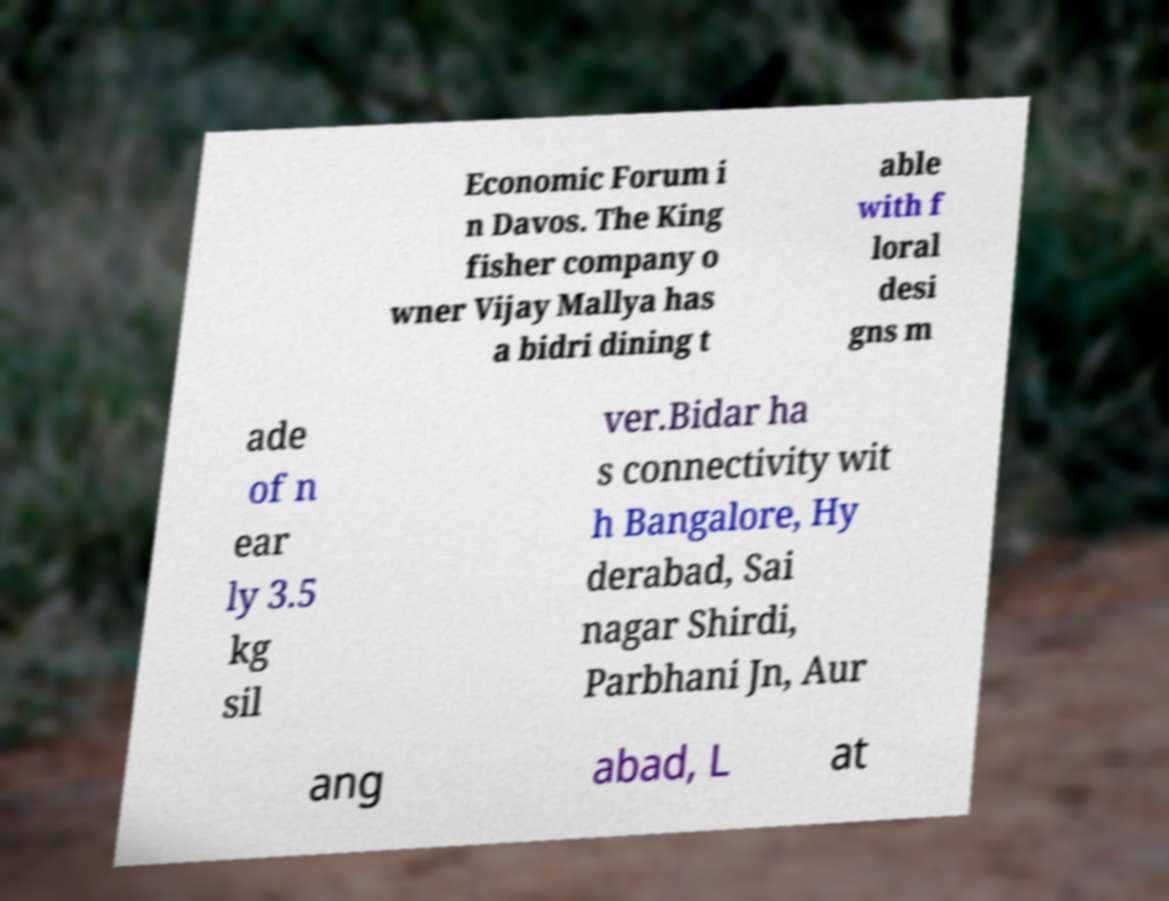There's text embedded in this image that I need extracted. Can you transcribe it verbatim? Economic Forum i n Davos. The King fisher company o wner Vijay Mallya has a bidri dining t able with f loral desi gns m ade of n ear ly 3.5 kg sil ver.Bidar ha s connectivity wit h Bangalore, Hy derabad, Sai nagar Shirdi, Parbhani Jn, Aur ang abad, L at 